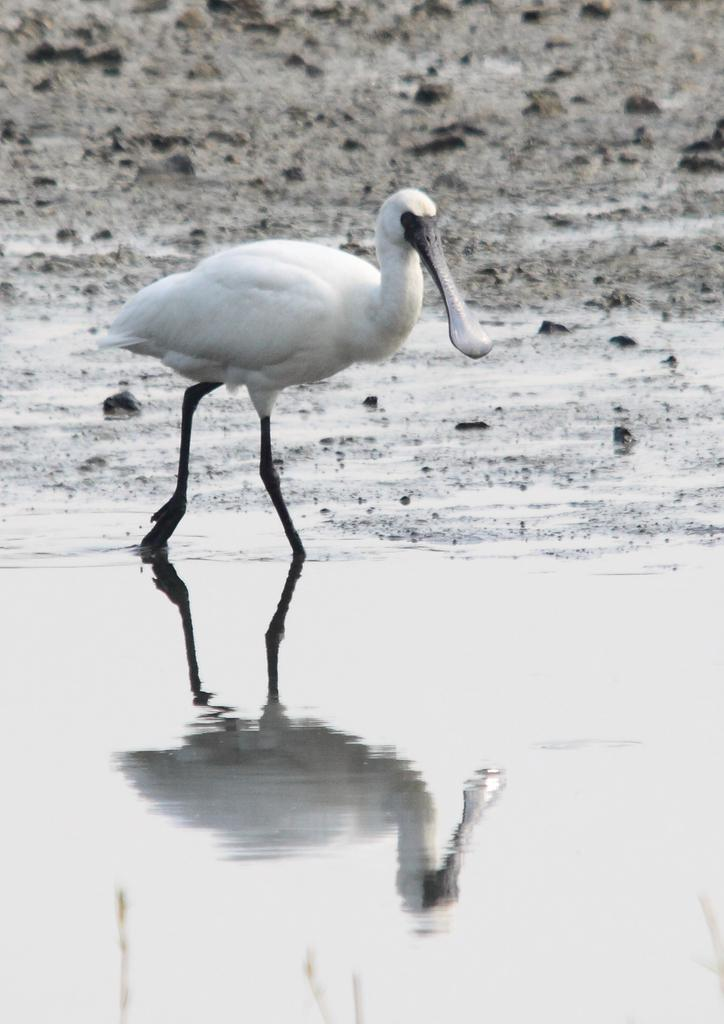What is the main subject in the middle of the image? There is a bird in the middle of the image. What can be seen in the background of the image? There is water visible in the image. What unit of measurement is the bird holding in the image? There is no unit of measurement present in the image; it features a bird and water. What advice does the bird's dad give in the image? There is no mention of the bird's dad or any advice in the image. 